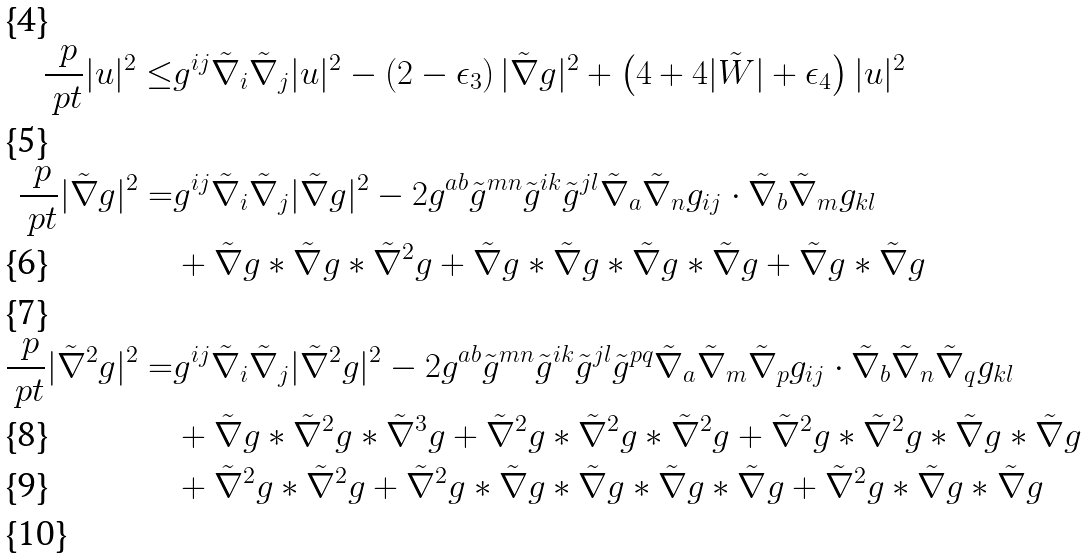Convert formula to latex. <formula><loc_0><loc_0><loc_500><loc_500>\frac { \ p } { \ p t } | u | ^ { 2 } \leq & g ^ { i j } \tilde { \nabla } _ { i } \tilde { \nabla } _ { j } | u | ^ { 2 } - \left ( 2 - \epsilon _ { 3 } \right ) | \tilde { \nabla } g | ^ { 2 } + \left ( 4 + 4 | \tilde { W } | + \epsilon _ { 4 } \right ) | u | ^ { 2 } \\ \frac { \ p } { \ p t } | \tilde { \nabla } g | ^ { 2 } = & g ^ { i j } \tilde { \nabla } _ { i } \tilde { \nabla } _ { j } | \tilde { \nabla } g | ^ { 2 } - 2 g ^ { a b } \tilde { g } ^ { m n } \tilde { g } ^ { i k } \tilde { g } ^ { j l } \tilde { \nabla } _ { a } \tilde { \nabla } _ { n } g _ { i j } \cdot \tilde { \nabla } _ { b } \tilde { \nabla } _ { m } g _ { k l } \\ & + \tilde { \nabla } g \ast \tilde { \nabla } g \ast \tilde { \nabla } ^ { 2 } g + \tilde { \nabla } g \ast \tilde { \nabla } g \ast \tilde { \nabla } g \ast \tilde { \nabla } g + \tilde { \nabla } g \ast \tilde { \nabla } g \\ \frac { \ p } { \ p t } | \tilde { \nabla } ^ { 2 } g | ^ { 2 } = & g ^ { i j } \tilde { \nabla } _ { i } \tilde { \nabla } _ { j } | \tilde { \nabla } ^ { 2 } g | ^ { 2 } - 2 g ^ { a b } \tilde { g } ^ { m n } \tilde { g } ^ { i k } \tilde { g } ^ { j l } \tilde { g } ^ { p q } \tilde { \nabla } _ { a } \tilde { \nabla } _ { m } \tilde { \nabla } _ { p } g _ { i j } \cdot \tilde { \nabla } _ { b } \tilde { \nabla } _ { n } \tilde { \nabla } _ { q } g _ { k l } \\ & + \tilde { \nabla } g \ast \tilde { \nabla } ^ { 2 } g \ast \tilde { \nabla } ^ { 3 } g + \tilde { \nabla } ^ { 2 } g \ast \tilde { \nabla } ^ { 2 } g \ast \tilde { \nabla } ^ { 2 } g + \tilde { \nabla } ^ { 2 } g \ast \tilde { \nabla } ^ { 2 } g \ast \tilde { \nabla } g \ast \tilde { \nabla } g \\ & + \tilde { \nabla } ^ { 2 } g \ast \tilde { \nabla } ^ { 2 } g + \tilde { \nabla } ^ { 2 } g \ast \tilde { \nabla } g \ast \tilde { \nabla } g \ast \tilde { \nabla } g \ast \tilde { \nabla } g + \tilde { \nabla } ^ { 2 } g \ast \tilde { \nabla } g \ast \tilde { \nabla } g \\</formula> 